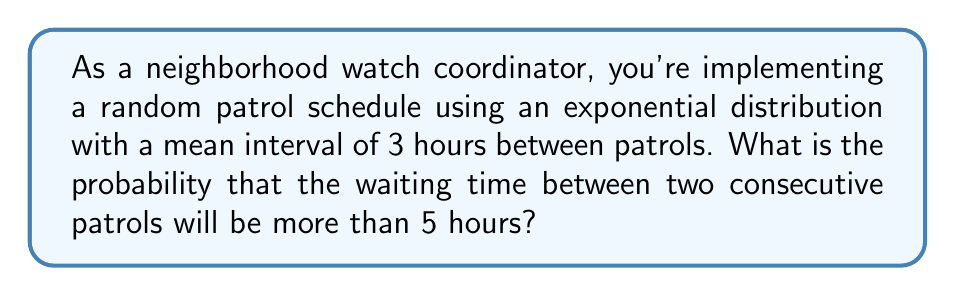What is the answer to this math problem? Let's approach this step-by-step:

1) The exponential distribution is often used to model the time between events in a Poisson process. In this case, it's modeling the time between patrols.

2) The probability density function of an exponential distribution is:

   $$f(x) = \lambda e^{-\lambda x}$$

   where $\lambda$ is the rate parameter.

3) We're given that the mean interval is 3 hours. For an exponential distribution, the mean is $\frac{1}{\lambda}$. So:

   $$\frac{1}{\lambda} = 3$$
   $$\lambda = \frac{1}{3}$$

4) We want to find $P(X > 5)$, where $X$ is the waiting time between patrols.

5) For an exponential distribution:

   $$P(X > x) = e^{-\lambda x}$$

6) Substituting our values:

   $$P(X > 5) = e^{-\frac{1}{3} \cdot 5}$$

7) Simplifying:

   $$P(X > 5) = e^{-\frac{5}{3}} \approx 0.1889$$

8) Converting to a percentage:

   $$0.1889 \cdot 100\% \approx 18.89\%$$
Answer: 18.89% 